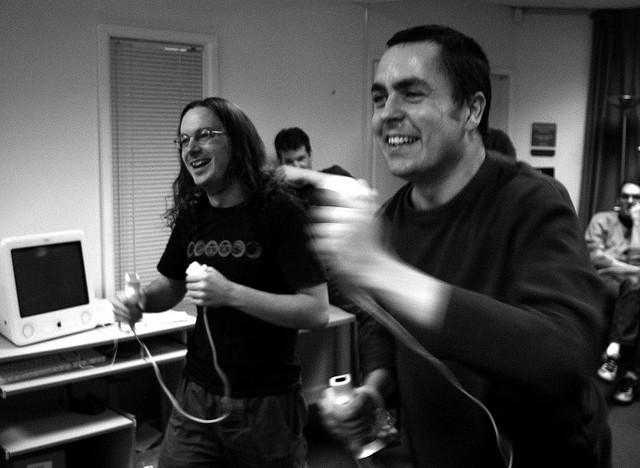What should be installed on the device with a screen? operating system 